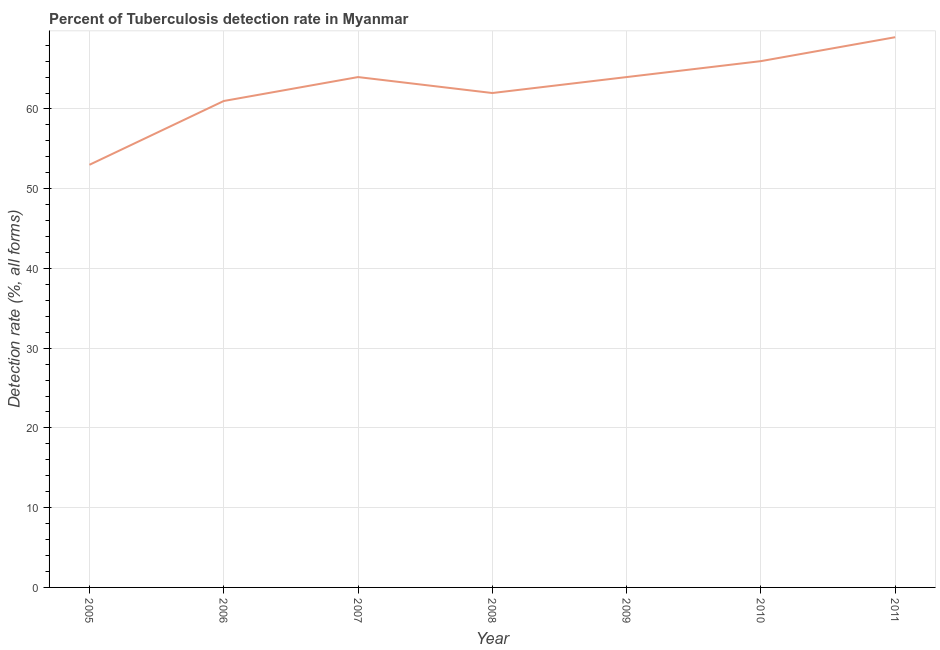What is the detection rate of tuberculosis in 2007?
Offer a terse response. 64. In which year was the detection rate of tuberculosis maximum?
Offer a terse response. 2011. What is the sum of the detection rate of tuberculosis?
Provide a succinct answer. 439. What is the average detection rate of tuberculosis per year?
Keep it short and to the point. 62.71. Do a majority of the years between 2009 and 2011 (inclusive) have detection rate of tuberculosis greater than 46 %?
Keep it short and to the point. Yes. What is the ratio of the detection rate of tuberculosis in 2008 to that in 2009?
Keep it short and to the point. 0.97. Is the difference between the detection rate of tuberculosis in 2005 and 2007 greater than the difference between any two years?
Ensure brevity in your answer.  No. What is the difference between the highest and the second highest detection rate of tuberculosis?
Make the answer very short. 3. Is the sum of the detection rate of tuberculosis in 2005 and 2007 greater than the maximum detection rate of tuberculosis across all years?
Provide a succinct answer. Yes. In how many years, is the detection rate of tuberculosis greater than the average detection rate of tuberculosis taken over all years?
Offer a very short reply. 4. Does the detection rate of tuberculosis monotonically increase over the years?
Make the answer very short. No. How many lines are there?
Provide a succinct answer. 1. How many years are there in the graph?
Provide a succinct answer. 7. What is the difference between two consecutive major ticks on the Y-axis?
Offer a terse response. 10. Are the values on the major ticks of Y-axis written in scientific E-notation?
Provide a short and direct response. No. Does the graph contain any zero values?
Ensure brevity in your answer.  No. Does the graph contain grids?
Your response must be concise. Yes. What is the title of the graph?
Offer a terse response. Percent of Tuberculosis detection rate in Myanmar. What is the label or title of the X-axis?
Offer a very short reply. Year. What is the label or title of the Y-axis?
Keep it short and to the point. Detection rate (%, all forms). What is the Detection rate (%, all forms) in 2006?
Keep it short and to the point. 61. What is the Detection rate (%, all forms) of 2008?
Your answer should be very brief. 62. What is the Detection rate (%, all forms) in 2010?
Offer a terse response. 66. What is the Detection rate (%, all forms) in 2011?
Offer a terse response. 69. What is the difference between the Detection rate (%, all forms) in 2005 and 2006?
Provide a short and direct response. -8. What is the difference between the Detection rate (%, all forms) in 2005 and 2008?
Offer a very short reply. -9. What is the difference between the Detection rate (%, all forms) in 2005 and 2009?
Your answer should be compact. -11. What is the difference between the Detection rate (%, all forms) in 2005 and 2011?
Your answer should be compact. -16. What is the difference between the Detection rate (%, all forms) in 2006 and 2008?
Keep it short and to the point. -1. What is the difference between the Detection rate (%, all forms) in 2006 and 2009?
Make the answer very short. -3. What is the difference between the Detection rate (%, all forms) in 2006 and 2010?
Your answer should be very brief. -5. What is the difference between the Detection rate (%, all forms) in 2006 and 2011?
Your response must be concise. -8. What is the difference between the Detection rate (%, all forms) in 2007 and 2008?
Keep it short and to the point. 2. What is the difference between the Detection rate (%, all forms) in 2007 and 2011?
Offer a very short reply. -5. What is the difference between the Detection rate (%, all forms) in 2008 and 2011?
Offer a terse response. -7. What is the difference between the Detection rate (%, all forms) in 2009 and 2010?
Provide a short and direct response. -2. What is the difference between the Detection rate (%, all forms) in 2009 and 2011?
Your answer should be very brief. -5. What is the ratio of the Detection rate (%, all forms) in 2005 to that in 2006?
Make the answer very short. 0.87. What is the ratio of the Detection rate (%, all forms) in 2005 to that in 2007?
Give a very brief answer. 0.83. What is the ratio of the Detection rate (%, all forms) in 2005 to that in 2008?
Ensure brevity in your answer.  0.85. What is the ratio of the Detection rate (%, all forms) in 2005 to that in 2009?
Give a very brief answer. 0.83. What is the ratio of the Detection rate (%, all forms) in 2005 to that in 2010?
Your answer should be compact. 0.8. What is the ratio of the Detection rate (%, all forms) in 2005 to that in 2011?
Your response must be concise. 0.77. What is the ratio of the Detection rate (%, all forms) in 2006 to that in 2007?
Provide a succinct answer. 0.95. What is the ratio of the Detection rate (%, all forms) in 2006 to that in 2008?
Make the answer very short. 0.98. What is the ratio of the Detection rate (%, all forms) in 2006 to that in 2009?
Give a very brief answer. 0.95. What is the ratio of the Detection rate (%, all forms) in 2006 to that in 2010?
Offer a very short reply. 0.92. What is the ratio of the Detection rate (%, all forms) in 2006 to that in 2011?
Offer a terse response. 0.88. What is the ratio of the Detection rate (%, all forms) in 2007 to that in 2008?
Keep it short and to the point. 1.03. What is the ratio of the Detection rate (%, all forms) in 2007 to that in 2011?
Ensure brevity in your answer.  0.93. What is the ratio of the Detection rate (%, all forms) in 2008 to that in 2009?
Make the answer very short. 0.97. What is the ratio of the Detection rate (%, all forms) in 2008 to that in 2010?
Provide a succinct answer. 0.94. What is the ratio of the Detection rate (%, all forms) in 2008 to that in 2011?
Your response must be concise. 0.9. What is the ratio of the Detection rate (%, all forms) in 2009 to that in 2011?
Give a very brief answer. 0.93. What is the ratio of the Detection rate (%, all forms) in 2010 to that in 2011?
Provide a short and direct response. 0.96. 